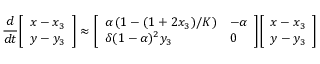<formula> <loc_0><loc_0><loc_500><loc_500>{ \frac { d } { d t } } { \left [ \begin{array} { l } { x - x _ { 3 } } \\ { y - y _ { 3 } } \end{array} \right ] } \approx { \left [ \begin{array} { l l } { \alpha \left ( 1 - ( 1 + 2 x _ { 3 } ) / K \right ) } & { - \alpha } \\ { \delta ( 1 - \alpha ) ^ { 2 } y _ { 3 } } & { 0 } \end{array} \right ] } { \left [ \begin{array} { l } { x - x _ { 3 } } \\ { y - y _ { 3 } } \end{array} \right ] }</formula> 